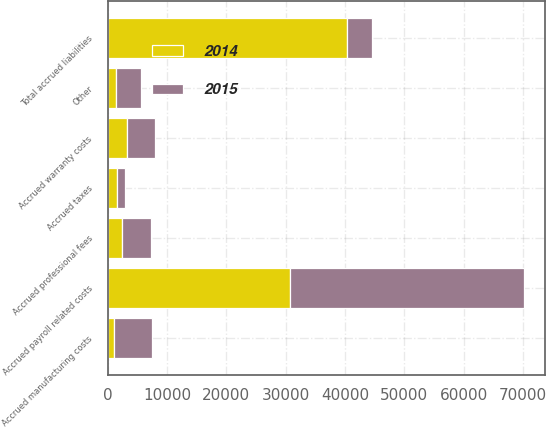Convert chart to OTSL. <chart><loc_0><loc_0><loc_500><loc_500><stacked_bar_chart><ecel><fcel>Accrued payroll related costs<fcel>Accrued warranty costs<fcel>Accrued manufacturing costs<fcel>Accrued professional fees<fcel>Accrued taxes<fcel>Other<fcel>Total accrued liabilities<nl><fcel>2015<fcel>39479<fcel>4718<fcel>6397<fcel>4875<fcel>1347<fcel>4155<fcel>4155<nl><fcel>2014<fcel>30749<fcel>3204<fcel>1089<fcel>2354<fcel>1577<fcel>1396<fcel>40369<nl></chart> 